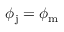<formula> <loc_0><loc_0><loc_500><loc_500>\phi _ { j } = \phi _ { m }</formula> 